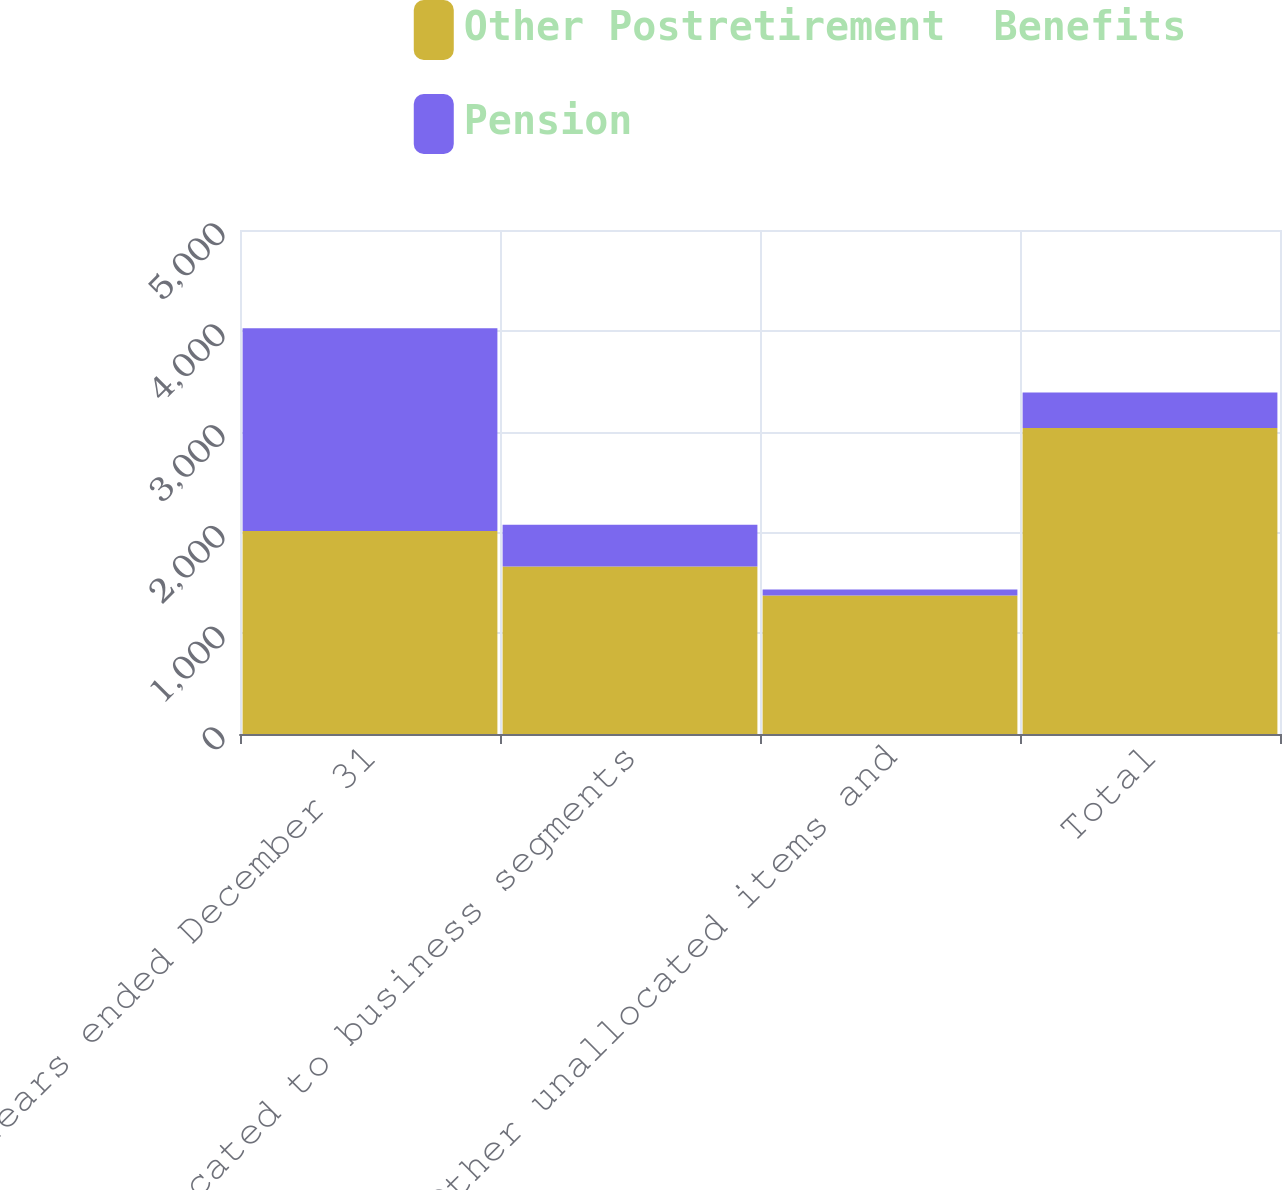Convert chart. <chart><loc_0><loc_0><loc_500><loc_500><stacked_bar_chart><ecel><fcel>Years ended December 31<fcel>Allocated to business segments<fcel>Other unallocated items and<fcel>Total<nl><fcel>Other Postretirement  Benefits<fcel>2013<fcel>1662<fcel>1374<fcel>3036<nl><fcel>Pension<fcel>2013<fcel>413<fcel>60<fcel>353<nl></chart> 